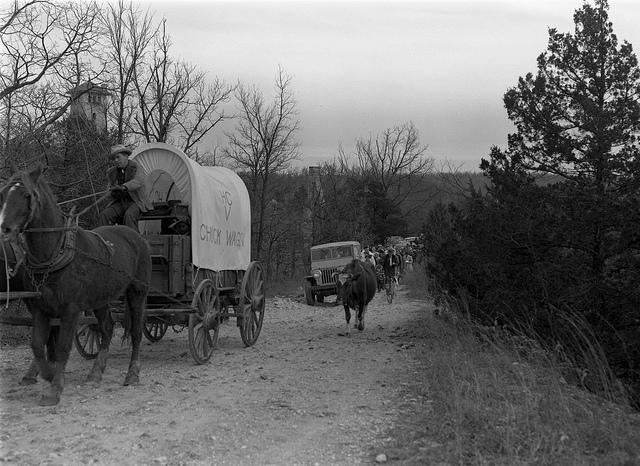Is there a shadow in the picture?
Write a very short answer. No. What is the animal with the stripes?
Concise answer only. Horse. What is the occupation of the man on horseback?
Be succinct. Cowboy. What color are the cows?
Short answer required. Brown. Why is the horse on the ground?
Quick response, please. Walking. What vehicle is the man driving?
Quick response, please. Wagon. What type of vehicle is in the lead of the line?
Write a very short answer. Wagon. What vehicle is in the background?
Keep it brief. Jeep. Is there snow on the ground?
Write a very short answer. No. Do you see any horses?
Short answer required. Yes. What covers the ground?
Quick response, please. Dirt. Is there a gazebo in this shot?
Be succinct. No. What number of horses are on the road?
Answer briefly. 2. Is it snowing out?
Short answer required. No. Is this a busy city?
Quick response, please. No. What type of vehicle is this?
Keep it brief. Wagon. What does it say on the side of the wagon?
Write a very short answer. Chuck wagon. Is it cold out?
Keep it brief. No. What are the people riding in?
Short answer required. Wagon. 